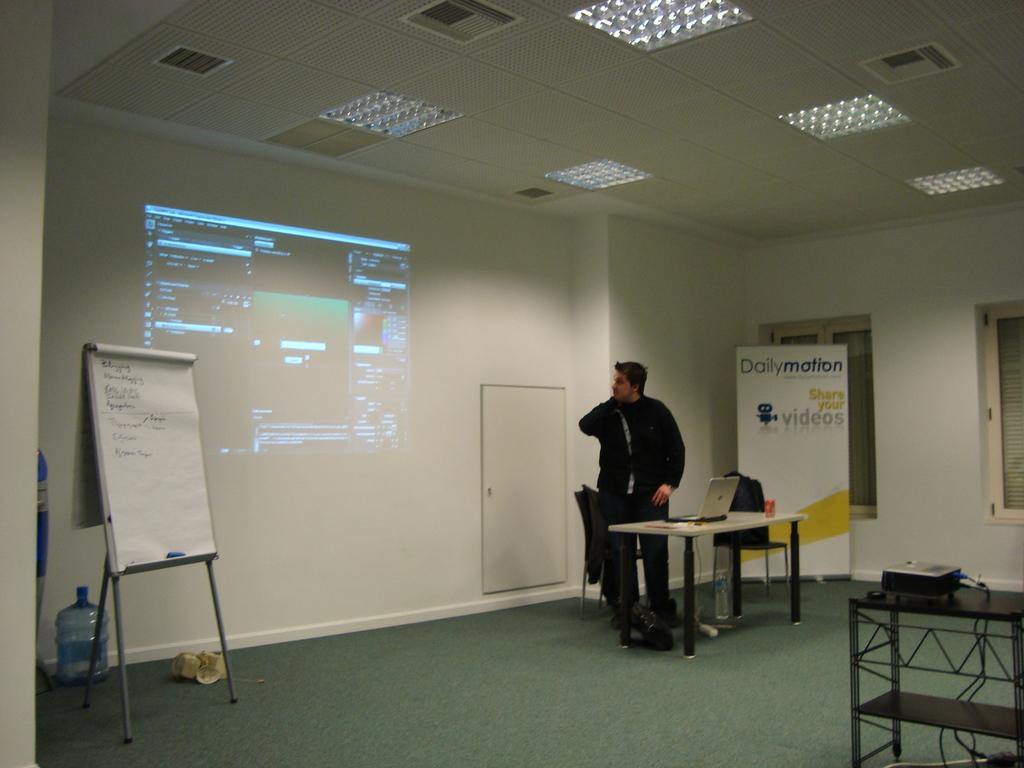Provide a one-sentence caption for the provided image. A man in front of a sign for Dailymotion is displaying a presentation. 